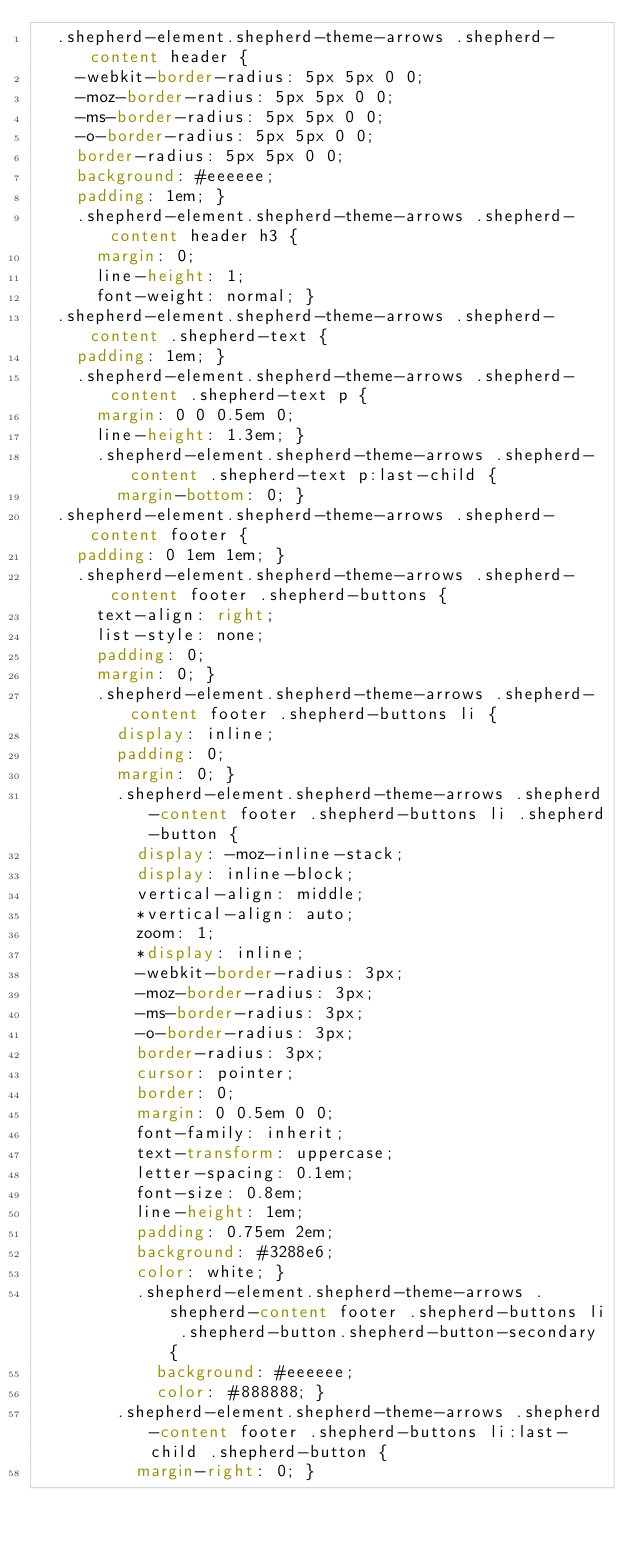<code> <loc_0><loc_0><loc_500><loc_500><_CSS_>  .shepherd-element.shepherd-theme-arrows .shepherd-content header {
    -webkit-border-radius: 5px 5px 0 0;
    -moz-border-radius: 5px 5px 0 0;
    -ms-border-radius: 5px 5px 0 0;
    -o-border-radius: 5px 5px 0 0;
    border-radius: 5px 5px 0 0;
    background: #eeeeee;
    padding: 1em; }
    .shepherd-element.shepherd-theme-arrows .shepherd-content header h3 {
      margin: 0;
      line-height: 1;
      font-weight: normal; }
  .shepherd-element.shepherd-theme-arrows .shepherd-content .shepherd-text {
    padding: 1em; }
    .shepherd-element.shepherd-theme-arrows .shepherd-content .shepherd-text p {
      margin: 0 0 0.5em 0;
      line-height: 1.3em; }
      .shepherd-element.shepherd-theme-arrows .shepherd-content .shepherd-text p:last-child {
        margin-bottom: 0; }
  .shepherd-element.shepherd-theme-arrows .shepherd-content footer {
    padding: 0 1em 1em; }
    .shepherd-element.shepherd-theme-arrows .shepherd-content footer .shepherd-buttons {
      text-align: right;
      list-style: none;
      padding: 0;
      margin: 0; }
      .shepherd-element.shepherd-theme-arrows .shepherd-content footer .shepherd-buttons li {
        display: inline;
        padding: 0;
        margin: 0; }
        .shepherd-element.shepherd-theme-arrows .shepherd-content footer .shepherd-buttons li .shepherd-button {
          display: -moz-inline-stack;
          display: inline-block;
          vertical-align: middle;
          *vertical-align: auto;
          zoom: 1;
          *display: inline;
          -webkit-border-radius: 3px;
          -moz-border-radius: 3px;
          -ms-border-radius: 3px;
          -o-border-radius: 3px;
          border-radius: 3px;
          cursor: pointer;
          border: 0;
          margin: 0 0.5em 0 0;
          font-family: inherit;
          text-transform: uppercase;
          letter-spacing: 0.1em;
          font-size: 0.8em;
          line-height: 1em;
          padding: 0.75em 2em;
          background: #3288e6;
          color: white; }
          .shepherd-element.shepherd-theme-arrows .shepherd-content footer .shepherd-buttons li .shepherd-button.shepherd-button-secondary {
            background: #eeeeee;
            color: #888888; }
        .shepherd-element.shepherd-theme-arrows .shepherd-content footer .shepherd-buttons li:last-child .shepherd-button {
          margin-right: 0; }
</code> 